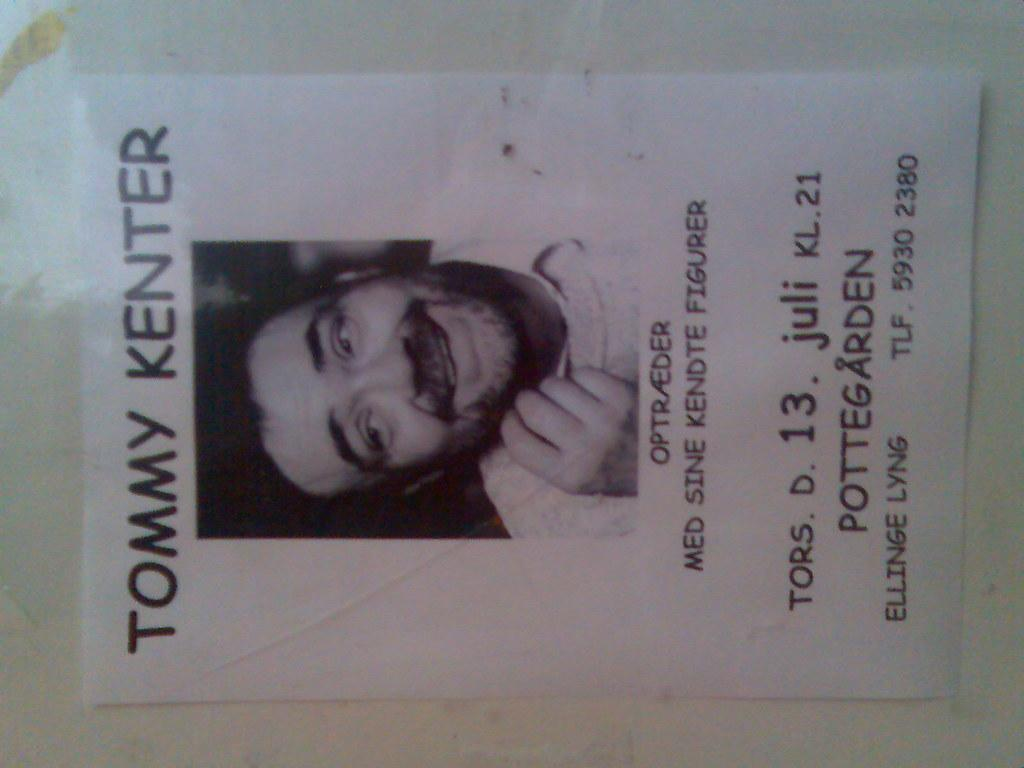Provide a one-sentence caption for the provided image. A photo of  a man named Tommy Kenter is on a homemade flyer that has been taped to a wall. 